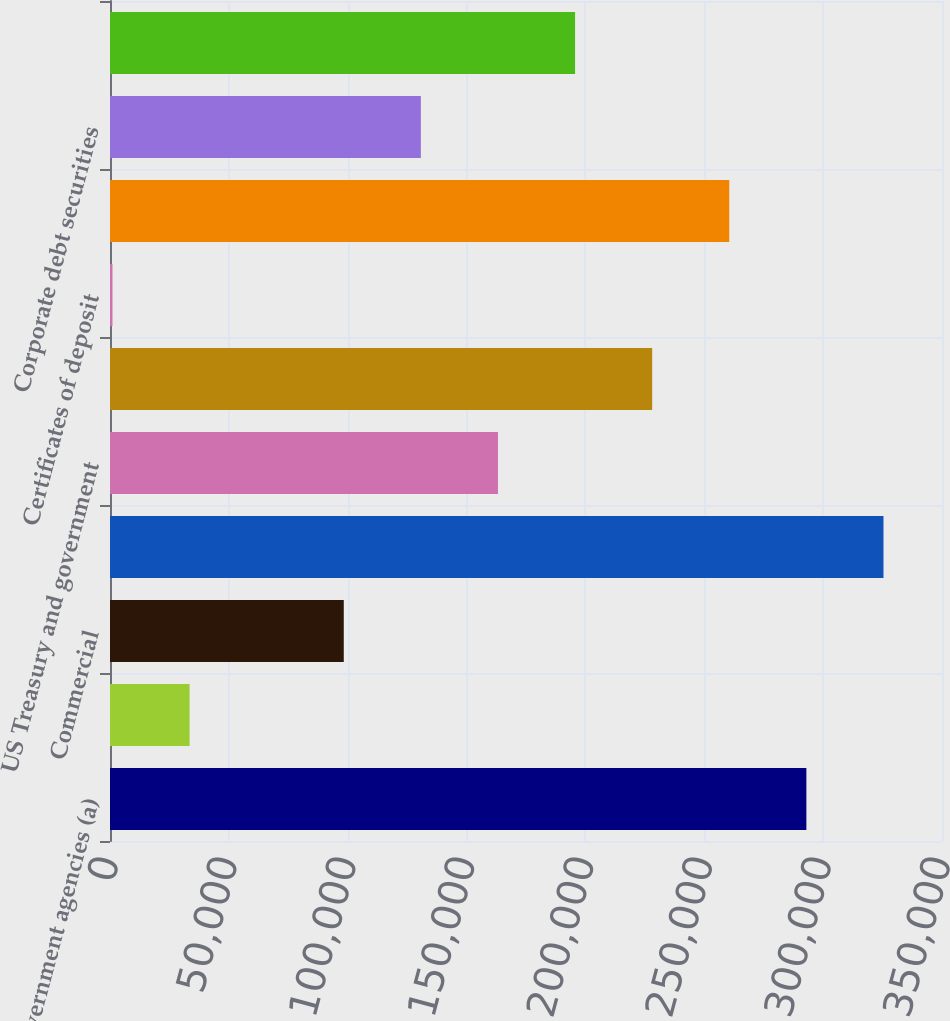Convert chart to OTSL. <chart><loc_0><loc_0><loc_500><loc_500><bar_chart><fcel>US government agencies (a)<fcel>Prime and Alt-A<fcel>Commercial<fcel>Total mortgage-backed<fcel>US Treasury and government<fcel>Obligations of US states and<fcel>Certificates of deposit<fcel>Non-US government debt<fcel>Corporate debt securities<fcel>Collateralized loan<nl><fcel>292944<fcel>33474.7<fcel>98342.1<fcel>325378<fcel>163210<fcel>228077<fcel>1041<fcel>260511<fcel>130776<fcel>195643<nl></chart> 